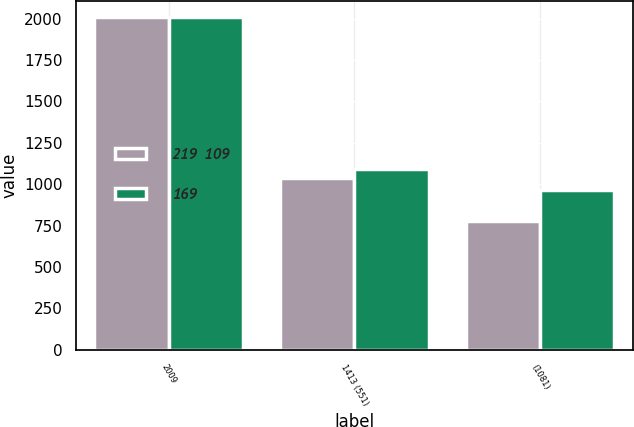Convert chart to OTSL. <chart><loc_0><loc_0><loc_500><loc_500><stacked_bar_chart><ecel><fcel>2009<fcel>1413 (551)<fcel>(1081)<nl><fcel>219  109<fcel>2008<fcel>1039<fcel>779<nl><fcel>169<fcel>2007<fcel>1094<fcel>963<nl></chart> 